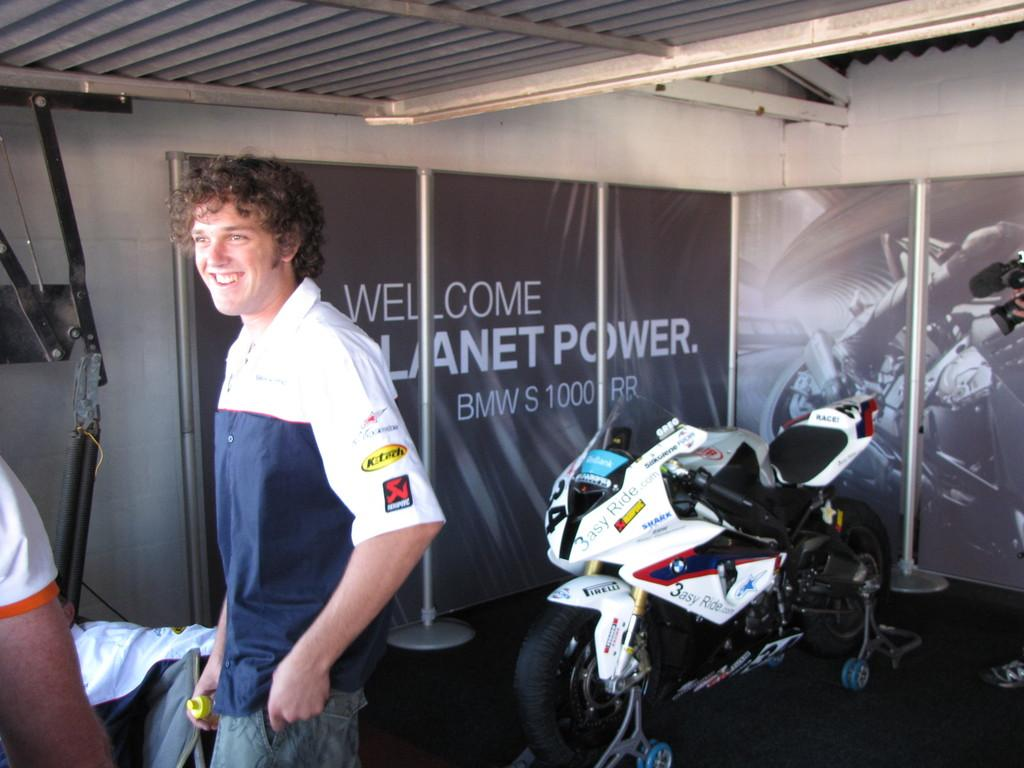Who is present in the image? There is a man in the image. What is the man's facial expression? The man is smiling. What can be seen in the background of the image? There is a bike and a poster in the background of the image. What is in front of the poster? There are poles in front of the poster. Where is the baby in the image? There is no baby present in the image. What type of cover is on the bike in the image? There is no cover on the bike in the image. 